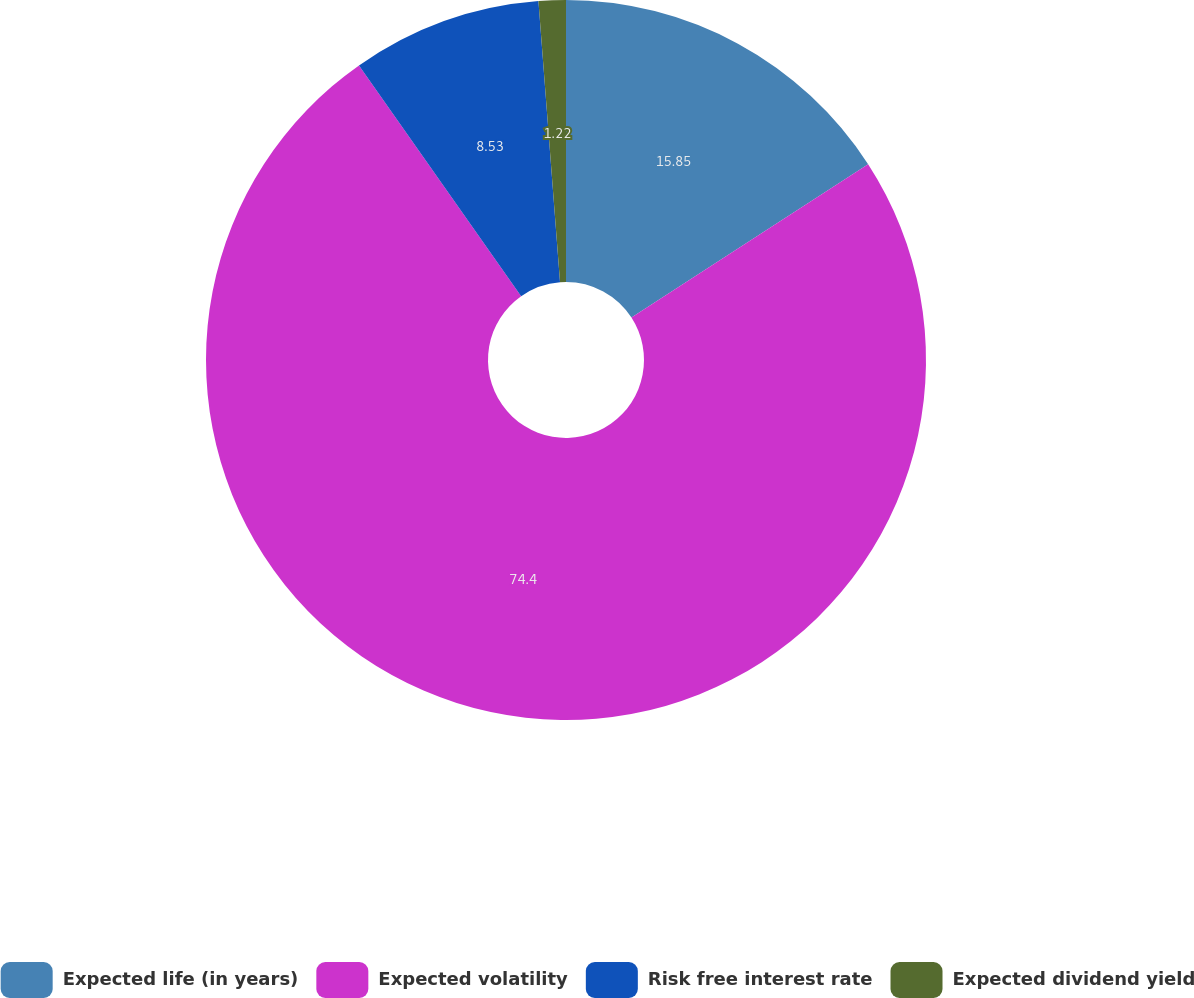<chart> <loc_0><loc_0><loc_500><loc_500><pie_chart><fcel>Expected life (in years)<fcel>Expected volatility<fcel>Risk free interest rate<fcel>Expected dividend yield<nl><fcel>15.85%<fcel>74.4%<fcel>8.53%<fcel>1.22%<nl></chart> 